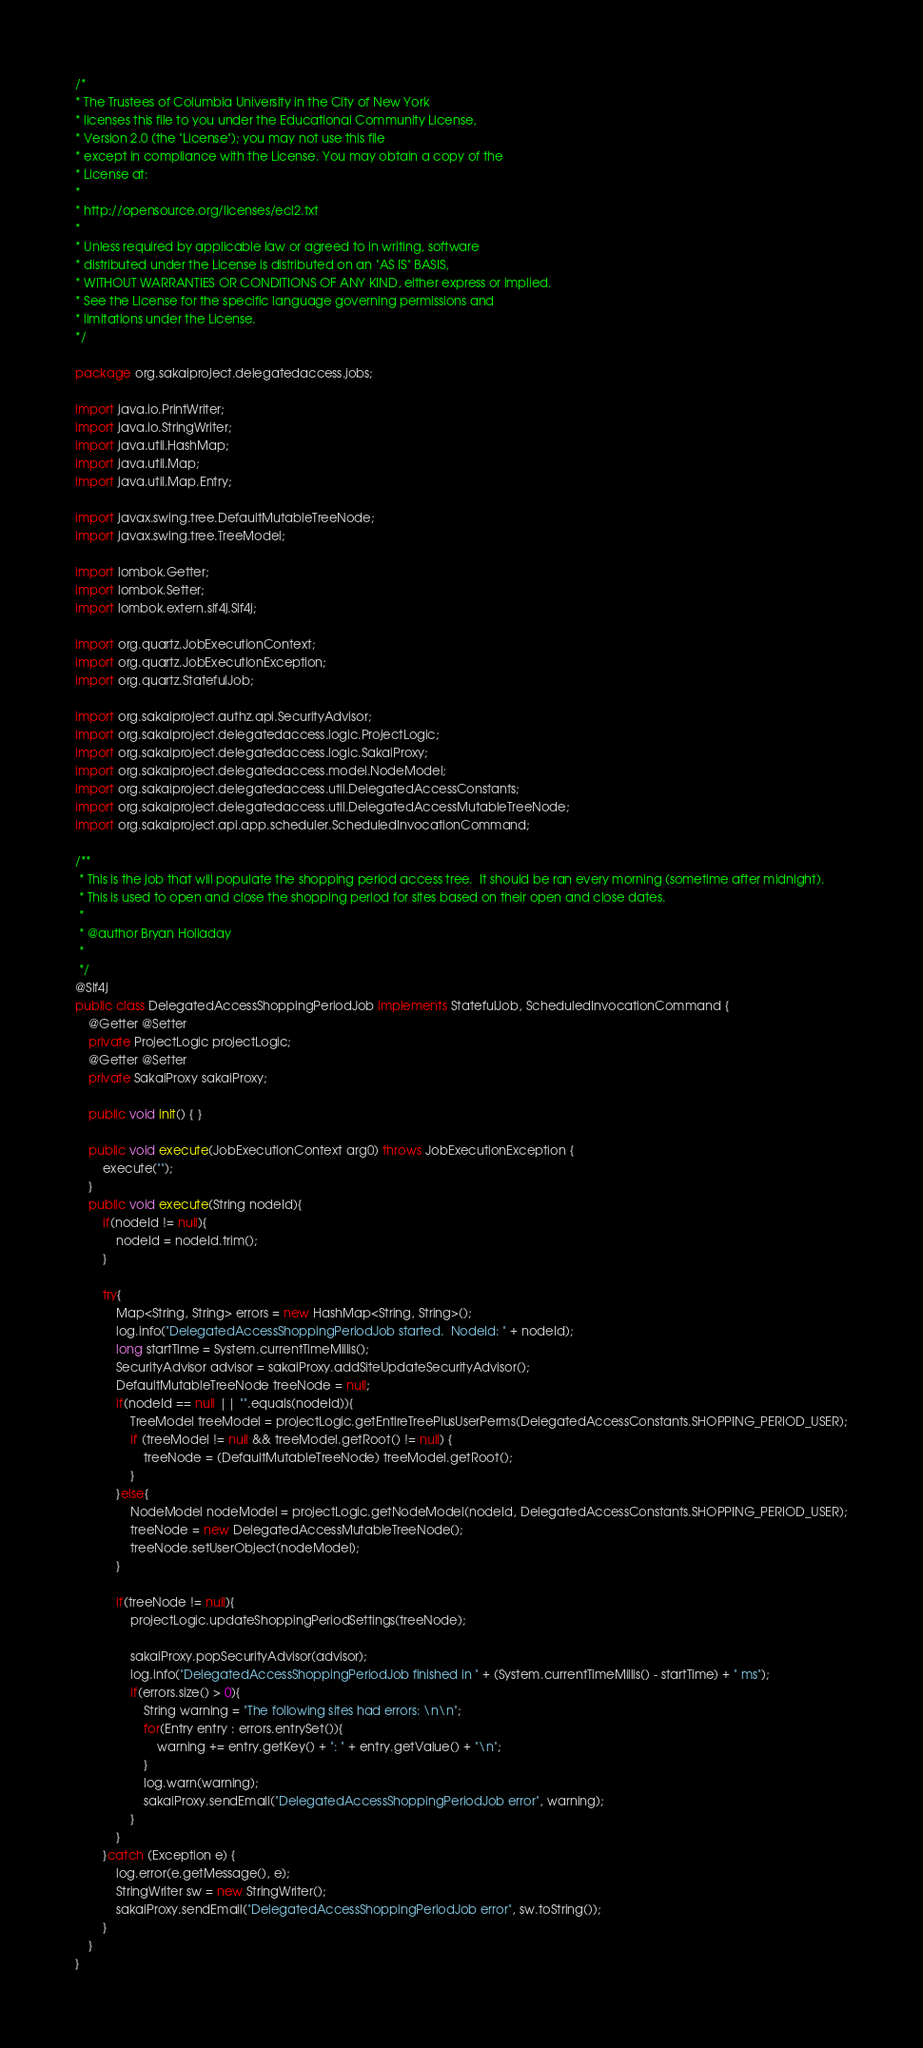Convert code to text. <code><loc_0><loc_0><loc_500><loc_500><_Java_>/*
* The Trustees of Columbia University in the City of New York
* licenses this file to you under the Educational Community License,
* Version 2.0 (the "License"); you may not use this file
* except in compliance with the License. You may obtain a copy of the
* License at:
*
* http://opensource.org/licenses/ecl2.txt
*
* Unless required by applicable law or agreed to in writing, software
* distributed under the License is distributed on an "AS IS" BASIS,
* WITHOUT WARRANTIES OR CONDITIONS OF ANY KIND, either express or implied.
* See the License for the specific language governing permissions and
* limitations under the License.
*/

package org.sakaiproject.delegatedaccess.jobs;

import java.io.PrintWriter;
import java.io.StringWriter;
import java.util.HashMap;
import java.util.Map;
import java.util.Map.Entry;

import javax.swing.tree.DefaultMutableTreeNode;
import javax.swing.tree.TreeModel;

import lombok.Getter;
import lombok.Setter;
import lombok.extern.slf4j.Slf4j;

import org.quartz.JobExecutionContext;
import org.quartz.JobExecutionException;
import org.quartz.StatefulJob;

import org.sakaiproject.authz.api.SecurityAdvisor;
import org.sakaiproject.delegatedaccess.logic.ProjectLogic;
import org.sakaiproject.delegatedaccess.logic.SakaiProxy;
import org.sakaiproject.delegatedaccess.model.NodeModel;
import org.sakaiproject.delegatedaccess.util.DelegatedAccessConstants;
import org.sakaiproject.delegatedaccess.util.DelegatedAccessMutableTreeNode;
import org.sakaiproject.api.app.scheduler.ScheduledInvocationCommand;

/**
 * This is the job that will populate the shopping period access tree.  It should be ran every morning (sometime after midnight).  
 * This is used to open and close the shopping period for sites based on their open and close dates.
 * 
 * @author Bryan Holladay
 *
 */
@Slf4j
public class DelegatedAccessShoppingPeriodJob implements StatefulJob, ScheduledInvocationCommand {
	@Getter @Setter
	private ProjectLogic projectLogic;
	@Getter @Setter	
	private SakaiProxy sakaiProxy;
	
	public void init() { }

	public void execute(JobExecutionContext arg0) throws JobExecutionException {
		execute("");
	}
	public void execute(String nodeId){
		if(nodeId != null){
			nodeId = nodeId.trim();
		}
		
		try{
			Map<String, String> errors = new HashMap<String, String>();
			log.info("DelegatedAccessShoppingPeriodJob started.  NodeId: " + nodeId);
			long startTime = System.currentTimeMillis();
			SecurityAdvisor advisor = sakaiProxy.addSiteUpdateSecurityAdvisor();
			DefaultMutableTreeNode treeNode = null;
			if(nodeId == null || "".equals(nodeId)){
				TreeModel treeModel = projectLogic.getEntireTreePlusUserPerms(DelegatedAccessConstants.SHOPPING_PERIOD_USER);
				if (treeModel != null && treeModel.getRoot() != null) {
					treeNode = (DefaultMutableTreeNode) treeModel.getRoot();
				}
			}else{
				NodeModel nodeModel = projectLogic.getNodeModel(nodeId, DelegatedAccessConstants.SHOPPING_PERIOD_USER);
				treeNode = new DelegatedAccessMutableTreeNode();
				treeNode.setUserObject(nodeModel);
			}
			
			if(treeNode != null){
				projectLogic.updateShoppingPeriodSettings(treeNode);
			
				sakaiProxy.popSecurityAdvisor(advisor);
				log.info("DelegatedAccessShoppingPeriodJob finished in " + (System.currentTimeMillis() - startTime) + " ms");
				if(errors.size() > 0){
					String warning = "The following sites had errors: \n\n";
					for(Entry entry : errors.entrySet()){
						warning += entry.getKey() + ": " + entry.getValue() + "\n";
					}
					log.warn(warning);
					sakaiProxy.sendEmail("DelegatedAccessShoppingPeriodJob error", warning);
				}
			}
		}catch (Exception e) {
			log.error(e.getMessage(), e);
			StringWriter sw = new StringWriter();
			sakaiProxy.sendEmail("DelegatedAccessShoppingPeriodJob error", sw.toString());
		}
	}
}
</code> 